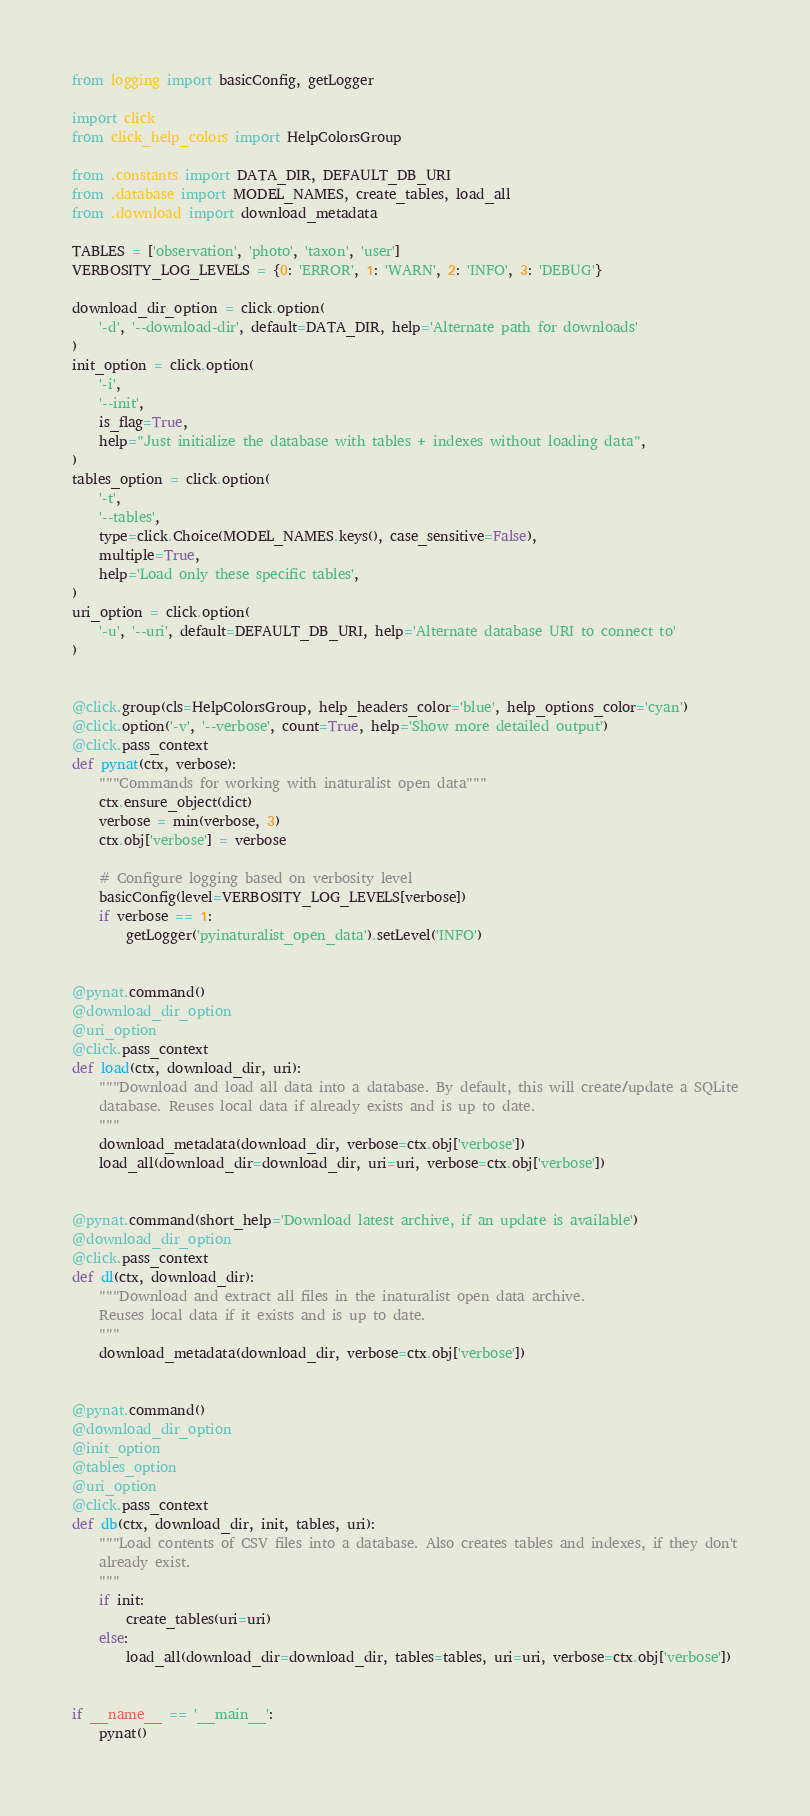<code> <loc_0><loc_0><loc_500><loc_500><_Python_>from logging import basicConfig, getLogger

import click
from click_help_colors import HelpColorsGroup

from .constants import DATA_DIR, DEFAULT_DB_URI
from .database import MODEL_NAMES, create_tables, load_all
from .download import download_metadata

TABLES = ['observation', 'photo', 'taxon', 'user']
VERBOSITY_LOG_LEVELS = {0: 'ERROR', 1: 'WARN', 2: 'INFO', 3: 'DEBUG'}

download_dir_option = click.option(
    '-d', '--download-dir', default=DATA_DIR, help='Alternate path for downloads'
)
init_option = click.option(
    '-i',
    '--init',
    is_flag=True,
    help="Just initialize the database with tables + indexes without loading data",
)
tables_option = click.option(
    '-t',
    '--tables',
    type=click.Choice(MODEL_NAMES.keys(), case_sensitive=False),
    multiple=True,
    help='Load only these specific tables',
)
uri_option = click.option(
    '-u', '--uri', default=DEFAULT_DB_URI, help='Alternate database URI to connect to'
)


@click.group(cls=HelpColorsGroup, help_headers_color='blue', help_options_color='cyan')
@click.option('-v', '--verbose', count=True, help='Show more detailed output')
@click.pass_context
def pynat(ctx, verbose):
    """Commands for working with inaturalist open data"""
    ctx.ensure_object(dict)
    verbose = min(verbose, 3)
    ctx.obj['verbose'] = verbose

    # Configure logging based on verbosity level
    basicConfig(level=VERBOSITY_LOG_LEVELS[verbose])
    if verbose == 1:
        getLogger('pyinaturalist_open_data').setLevel('INFO')


@pynat.command()
@download_dir_option
@uri_option
@click.pass_context
def load(ctx, download_dir, uri):
    """Download and load all data into a database. By default, this will create/update a SQLite
    database. Reuses local data if already exists and is up to date.
    """
    download_metadata(download_dir, verbose=ctx.obj['verbose'])
    load_all(download_dir=download_dir, uri=uri, verbose=ctx.obj['verbose'])


@pynat.command(short_help='Download latest archive, if an update is available')
@download_dir_option
@click.pass_context
def dl(ctx, download_dir):
    """Download and extract all files in the inaturalist open data archive.
    Reuses local data if it exists and is up to date.
    """
    download_metadata(download_dir, verbose=ctx.obj['verbose'])


@pynat.command()
@download_dir_option
@init_option
@tables_option
@uri_option
@click.pass_context
def db(ctx, download_dir, init, tables, uri):
    """Load contents of CSV files into a database. Also creates tables and indexes, if they don't
    already exist.
    """
    if init:
        create_tables(uri=uri)
    else:
        load_all(download_dir=download_dir, tables=tables, uri=uri, verbose=ctx.obj['verbose'])


if __name__ == '__main__':
    pynat()
</code> 